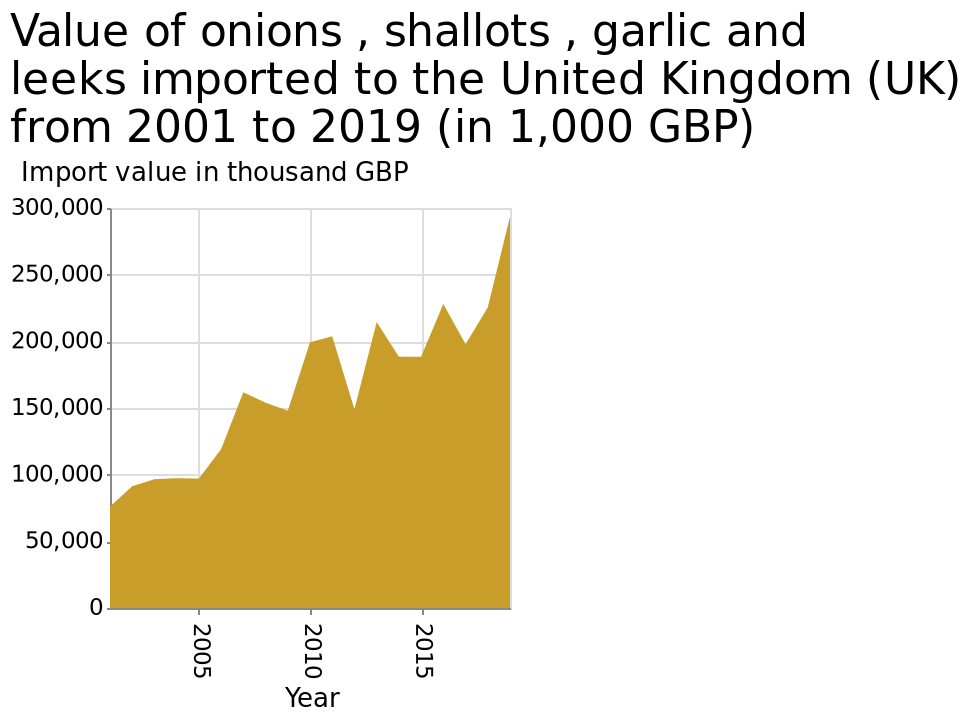<image>
How does the value fluctuate over time?  The value shows peaks and troughs throughout the years. What does the y-axis represent on the graph? The y-axis on the graph represents the import value in thousand GBP. please summary the statistics and relations of the chart The value appears to have peaks and troughs throughout the years. Offer a thorough analysis of the image. The value of onions, shallots and leeks imported to the UK has increased significantly from 2001 to 2019. What is the maximum value shown on the y-axis? The maximum value shown on the y-axis is 300,000 thousand GBP. 